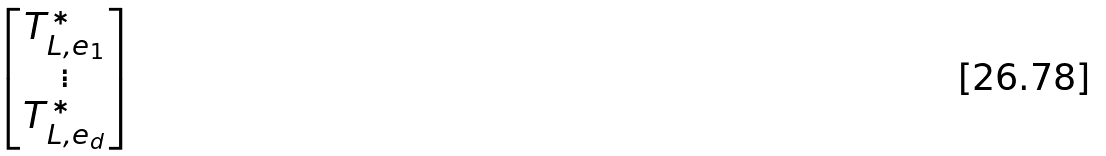<formula> <loc_0><loc_0><loc_500><loc_500>\begin{bmatrix} T _ { L , e _ { 1 } } ^ { * } \\ \vdots \\ T _ { L , e _ { d } } ^ { * } \end{bmatrix}</formula> 